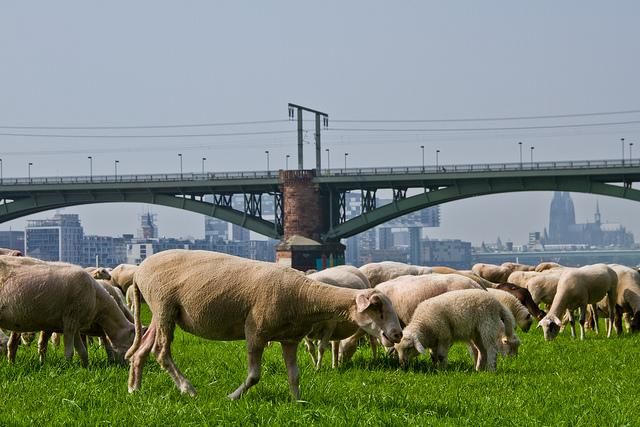What color is the cast iron component in the bridge above the grassy field? Please explain your reasoning. green. This is obvious in the scene and a common color used on steel bridges. 